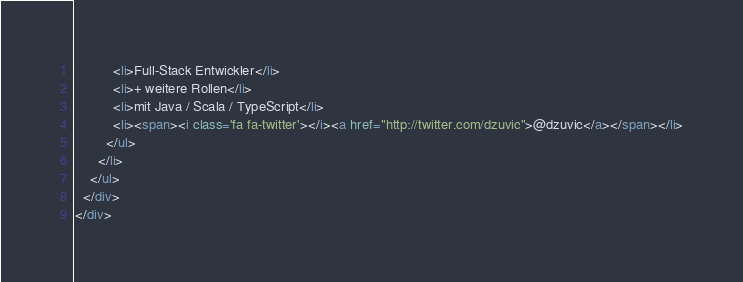Convert code to text. <code><loc_0><loc_0><loc_500><loc_500><_HTML_>          <li>Full-Stack Entwickler</li>
          <li>+ weitere Rollen</li>
          <li>mit Java / Scala / TypeScript</li>
          <li><span><i class='fa fa-twitter'></i><a href="http://twitter.com/dzuvic">@dzuvic</a></span></li>
        </ul>
      </li>
    </ul>
  </div>
</div>

</code> 